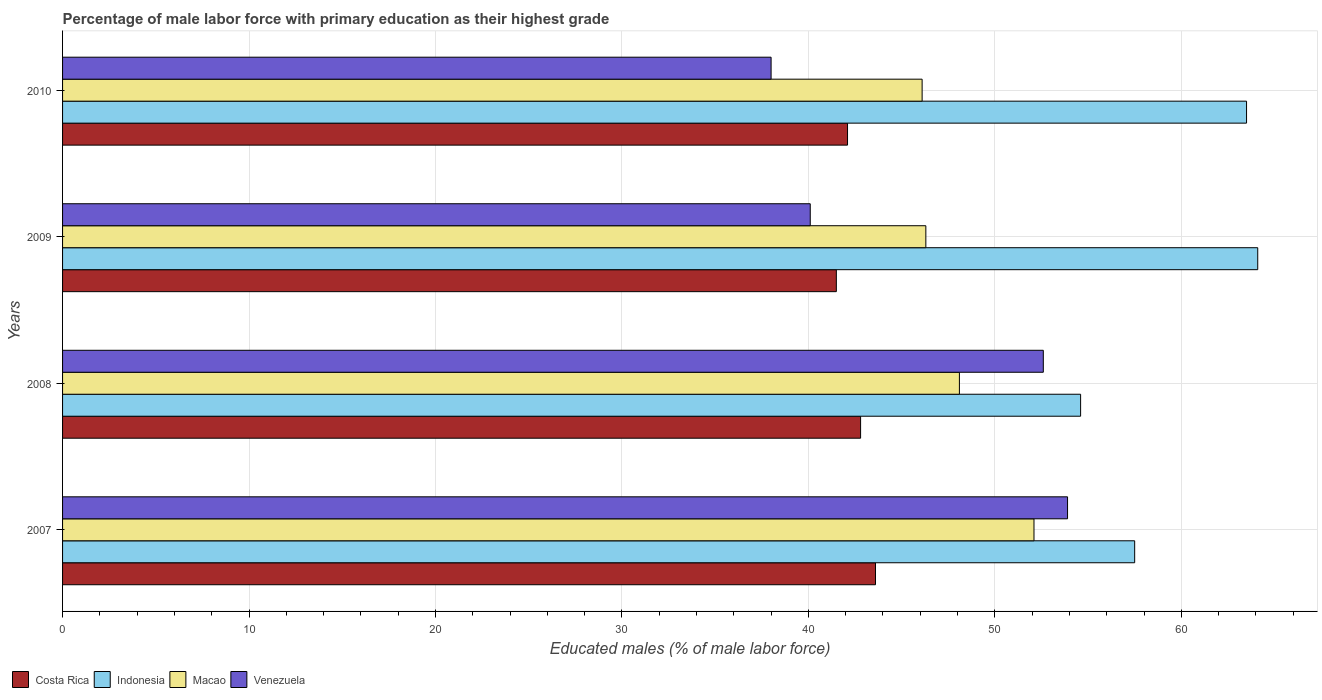How many different coloured bars are there?
Your response must be concise. 4. How many groups of bars are there?
Your answer should be compact. 4. Are the number of bars per tick equal to the number of legend labels?
Make the answer very short. Yes. How many bars are there on the 4th tick from the top?
Provide a short and direct response. 4. How many bars are there on the 1st tick from the bottom?
Provide a short and direct response. 4. What is the label of the 1st group of bars from the top?
Ensure brevity in your answer.  2010. In how many cases, is the number of bars for a given year not equal to the number of legend labels?
Provide a short and direct response. 0. What is the percentage of male labor force with primary education in Venezuela in 2007?
Offer a very short reply. 53.9. Across all years, what is the maximum percentage of male labor force with primary education in Venezuela?
Offer a very short reply. 53.9. Across all years, what is the minimum percentage of male labor force with primary education in Costa Rica?
Your answer should be very brief. 41.5. In which year was the percentage of male labor force with primary education in Macao maximum?
Your response must be concise. 2007. What is the total percentage of male labor force with primary education in Macao in the graph?
Offer a terse response. 192.6. What is the difference between the percentage of male labor force with primary education in Indonesia in 2007 and that in 2009?
Offer a very short reply. -6.6. What is the difference between the percentage of male labor force with primary education in Venezuela in 2009 and the percentage of male labor force with primary education in Indonesia in 2007?
Provide a succinct answer. -17.4. What is the average percentage of male labor force with primary education in Venezuela per year?
Provide a succinct answer. 46.15. In the year 2009, what is the difference between the percentage of male labor force with primary education in Venezuela and percentage of male labor force with primary education in Indonesia?
Offer a very short reply. -24. In how many years, is the percentage of male labor force with primary education in Costa Rica greater than 22 %?
Give a very brief answer. 4. What is the ratio of the percentage of male labor force with primary education in Indonesia in 2009 to that in 2010?
Your answer should be very brief. 1.01. In how many years, is the percentage of male labor force with primary education in Indonesia greater than the average percentage of male labor force with primary education in Indonesia taken over all years?
Give a very brief answer. 2. What does the 2nd bar from the top in 2007 represents?
Give a very brief answer. Macao. Is it the case that in every year, the sum of the percentage of male labor force with primary education in Venezuela and percentage of male labor force with primary education in Indonesia is greater than the percentage of male labor force with primary education in Macao?
Offer a very short reply. Yes. How many bars are there?
Give a very brief answer. 16. Are all the bars in the graph horizontal?
Keep it short and to the point. Yes. How many years are there in the graph?
Make the answer very short. 4. What is the difference between two consecutive major ticks on the X-axis?
Your answer should be compact. 10. Are the values on the major ticks of X-axis written in scientific E-notation?
Ensure brevity in your answer.  No. Does the graph contain grids?
Make the answer very short. Yes. What is the title of the graph?
Offer a terse response. Percentage of male labor force with primary education as their highest grade. Does "Cayman Islands" appear as one of the legend labels in the graph?
Keep it short and to the point. No. What is the label or title of the X-axis?
Provide a succinct answer. Educated males (% of male labor force). What is the Educated males (% of male labor force) in Costa Rica in 2007?
Offer a terse response. 43.6. What is the Educated males (% of male labor force) of Indonesia in 2007?
Provide a short and direct response. 57.5. What is the Educated males (% of male labor force) of Macao in 2007?
Keep it short and to the point. 52.1. What is the Educated males (% of male labor force) of Venezuela in 2007?
Give a very brief answer. 53.9. What is the Educated males (% of male labor force) in Costa Rica in 2008?
Offer a terse response. 42.8. What is the Educated males (% of male labor force) of Indonesia in 2008?
Provide a succinct answer. 54.6. What is the Educated males (% of male labor force) of Macao in 2008?
Give a very brief answer. 48.1. What is the Educated males (% of male labor force) of Venezuela in 2008?
Make the answer very short. 52.6. What is the Educated males (% of male labor force) in Costa Rica in 2009?
Offer a terse response. 41.5. What is the Educated males (% of male labor force) of Indonesia in 2009?
Make the answer very short. 64.1. What is the Educated males (% of male labor force) in Macao in 2009?
Keep it short and to the point. 46.3. What is the Educated males (% of male labor force) of Venezuela in 2009?
Provide a succinct answer. 40.1. What is the Educated males (% of male labor force) in Costa Rica in 2010?
Your answer should be very brief. 42.1. What is the Educated males (% of male labor force) in Indonesia in 2010?
Keep it short and to the point. 63.5. What is the Educated males (% of male labor force) in Macao in 2010?
Keep it short and to the point. 46.1. What is the Educated males (% of male labor force) of Venezuela in 2010?
Make the answer very short. 38. Across all years, what is the maximum Educated males (% of male labor force) in Costa Rica?
Your answer should be very brief. 43.6. Across all years, what is the maximum Educated males (% of male labor force) in Indonesia?
Offer a terse response. 64.1. Across all years, what is the maximum Educated males (% of male labor force) in Macao?
Offer a very short reply. 52.1. Across all years, what is the maximum Educated males (% of male labor force) of Venezuela?
Ensure brevity in your answer.  53.9. Across all years, what is the minimum Educated males (% of male labor force) in Costa Rica?
Offer a very short reply. 41.5. Across all years, what is the minimum Educated males (% of male labor force) of Indonesia?
Provide a succinct answer. 54.6. Across all years, what is the minimum Educated males (% of male labor force) in Macao?
Give a very brief answer. 46.1. What is the total Educated males (% of male labor force) of Costa Rica in the graph?
Make the answer very short. 170. What is the total Educated males (% of male labor force) in Indonesia in the graph?
Provide a short and direct response. 239.7. What is the total Educated males (% of male labor force) of Macao in the graph?
Offer a very short reply. 192.6. What is the total Educated males (% of male labor force) of Venezuela in the graph?
Keep it short and to the point. 184.6. What is the difference between the Educated males (% of male labor force) of Costa Rica in 2007 and that in 2008?
Provide a short and direct response. 0.8. What is the difference between the Educated males (% of male labor force) of Venezuela in 2007 and that in 2008?
Offer a terse response. 1.3. What is the difference between the Educated males (% of male labor force) in Indonesia in 2007 and that in 2009?
Offer a very short reply. -6.6. What is the difference between the Educated males (% of male labor force) of Indonesia in 2007 and that in 2010?
Make the answer very short. -6. What is the difference between the Educated males (% of male labor force) in Macao in 2007 and that in 2010?
Your answer should be compact. 6. What is the difference between the Educated males (% of male labor force) in Costa Rica in 2008 and that in 2009?
Your answer should be compact. 1.3. What is the difference between the Educated males (% of male labor force) in Macao in 2008 and that in 2009?
Keep it short and to the point. 1.8. What is the difference between the Educated males (% of male labor force) of Venezuela in 2008 and that in 2009?
Provide a succinct answer. 12.5. What is the difference between the Educated males (% of male labor force) in Indonesia in 2008 and that in 2010?
Offer a very short reply. -8.9. What is the difference between the Educated males (% of male labor force) in Macao in 2008 and that in 2010?
Ensure brevity in your answer.  2. What is the difference between the Educated males (% of male labor force) of Venezuela in 2008 and that in 2010?
Provide a short and direct response. 14.6. What is the difference between the Educated males (% of male labor force) in Macao in 2009 and that in 2010?
Provide a succinct answer. 0.2. What is the difference between the Educated males (% of male labor force) in Costa Rica in 2007 and the Educated males (% of male labor force) in Indonesia in 2008?
Give a very brief answer. -11. What is the difference between the Educated males (% of male labor force) of Costa Rica in 2007 and the Educated males (% of male labor force) of Venezuela in 2008?
Ensure brevity in your answer.  -9. What is the difference between the Educated males (% of male labor force) of Indonesia in 2007 and the Educated males (% of male labor force) of Macao in 2008?
Give a very brief answer. 9.4. What is the difference between the Educated males (% of male labor force) in Macao in 2007 and the Educated males (% of male labor force) in Venezuela in 2008?
Your answer should be very brief. -0.5. What is the difference between the Educated males (% of male labor force) of Costa Rica in 2007 and the Educated males (% of male labor force) of Indonesia in 2009?
Give a very brief answer. -20.5. What is the difference between the Educated males (% of male labor force) in Indonesia in 2007 and the Educated males (% of male labor force) in Macao in 2009?
Your response must be concise. 11.2. What is the difference between the Educated males (% of male labor force) in Costa Rica in 2007 and the Educated males (% of male labor force) in Indonesia in 2010?
Keep it short and to the point. -19.9. What is the difference between the Educated males (% of male labor force) of Costa Rica in 2007 and the Educated males (% of male labor force) of Macao in 2010?
Your answer should be compact. -2.5. What is the difference between the Educated males (% of male labor force) in Indonesia in 2007 and the Educated males (% of male labor force) in Macao in 2010?
Make the answer very short. 11.4. What is the difference between the Educated males (% of male labor force) in Indonesia in 2007 and the Educated males (% of male labor force) in Venezuela in 2010?
Your answer should be compact. 19.5. What is the difference between the Educated males (% of male labor force) in Macao in 2007 and the Educated males (% of male labor force) in Venezuela in 2010?
Make the answer very short. 14.1. What is the difference between the Educated males (% of male labor force) in Costa Rica in 2008 and the Educated males (% of male labor force) in Indonesia in 2009?
Keep it short and to the point. -21.3. What is the difference between the Educated males (% of male labor force) in Costa Rica in 2008 and the Educated males (% of male labor force) in Venezuela in 2009?
Provide a succinct answer. 2.7. What is the difference between the Educated males (% of male labor force) of Indonesia in 2008 and the Educated males (% of male labor force) of Macao in 2009?
Offer a very short reply. 8.3. What is the difference between the Educated males (% of male labor force) of Indonesia in 2008 and the Educated males (% of male labor force) of Venezuela in 2009?
Make the answer very short. 14.5. What is the difference between the Educated males (% of male labor force) of Macao in 2008 and the Educated males (% of male labor force) of Venezuela in 2009?
Your answer should be compact. 8. What is the difference between the Educated males (% of male labor force) of Costa Rica in 2008 and the Educated males (% of male labor force) of Indonesia in 2010?
Offer a very short reply. -20.7. What is the difference between the Educated males (% of male labor force) of Costa Rica in 2008 and the Educated males (% of male labor force) of Macao in 2010?
Make the answer very short. -3.3. What is the difference between the Educated males (% of male labor force) in Costa Rica in 2008 and the Educated males (% of male labor force) in Venezuela in 2010?
Give a very brief answer. 4.8. What is the difference between the Educated males (% of male labor force) in Indonesia in 2008 and the Educated males (% of male labor force) in Venezuela in 2010?
Your answer should be compact. 16.6. What is the difference between the Educated males (% of male labor force) of Costa Rica in 2009 and the Educated males (% of male labor force) of Indonesia in 2010?
Provide a short and direct response. -22. What is the difference between the Educated males (% of male labor force) of Indonesia in 2009 and the Educated males (% of male labor force) of Macao in 2010?
Give a very brief answer. 18. What is the difference between the Educated males (% of male labor force) of Indonesia in 2009 and the Educated males (% of male labor force) of Venezuela in 2010?
Your response must be concise. 26.1. What is the difference between the Educated males (% of male labor force) of Macao in 2009 and the Educated males (% of male labor force) of Venezuela in 2010?
Offer a terse response. 8.3. What is the average Educated males (% of male labor force) of Costa Rica per year?
Make the answer very short. 42.5. What is the average Educated males (% of male labor force) of Indonesia per year?
Make the answer very short. 59.92. What is the average Educated males (% of male labor force) in Macao per year?
Your answer should be very brief. 48.15. What is the average Educated males (% of male labor force) in Venezuela per year?
Make the answer very short. 46.15. In the year 2007, what is the difference between the Educated males (% of male labor force) in Costa Rica and Educated males (% of male labor force) in Macao?
Give a very brief answer. -8.5. In the year 2007, what is the difference between the Educated males (% of male labor force) of Indonesia and Educated males (% of male labor force) of Macao?
Your answer should be compact. 5.4. In the year 2008, what is the difference between the Educated males (% of male labor force) in Costa Rica and Educated males (% of male labor force) in Indonesia?
Offer a very short reply. -11.8. In the year 2008, what is the difference between the Educated males (% of male labor force) of Costa Rica and Educated males (% of male labor force) of Macao?
Keep it short and to the point. -5.3. In the year 2008, what is the difference between the Educated males (% of male labor force) of Indonesia and Educated males (% of male labor force) of Macao?
Keep it short and to the point. 6.5. In the year 2008, what is the difference between the Educated males (% of male labor force) in Indonesia and Educated males (% of male labor force) in Venezuela?
Your answer should be very brief. 2. In the year 2009, what is the difference between the Educated males (% of male labor force) in Costa Rica and Educated males (% of male labor force) in Indonesia?
Your answer should be compact. -22.6. In the year 2009, what is the difference between the Educated males (% of male labor force) in Indonesia and Educated males (% of male labor force) in Venezuela?
Your response must be concise. 24. In the year 2009, what is the difference between the Educated males (% of male labor force) in Macao and Educated males (% of male labor force) in Venezuela?
Keep it short and to the point. 6.2. In the year 2010, what is the difference between the Educated males (% of male labor force) of Costa Rica and Educated males (% of male labor force) of Indonesia?
Ensure brevity in your answer.  -21.4. In the year 2010, what is the difference between the Educated males (% of male labor force) in Costa Rica and Educated males (% of male labor force) in Macao?
Make the answer very short. -4. In the year 2010, what is the difference between the Educated males (% of male labor force) of Costa Rica and Educated males (% of male labor force) of Venezuela?
Offer a terse response. 4.1. What is the ratio of the Educated males (% of male labor force) in Costa Rica in 2007 to that in 2008?
Ensure brevity in your answer.  1.02. What is the ratio of the Educated males (% of male labor force) in Indonesia in 2007 to that in 2008?
Provide a short and direct response. 1.05. What is the ratio of the Educated males (% of male labor force) in Macao in 2007 to that in 2008?
Provide a succinct answer. 1.08. What is the ratio of the Educated males (% of male labor force) in Venezuela in 2007 to that in 2008?
Your answer should be very brief. 1.02. What is the ratio of the Educated males (% of male labor force) in Costa Rica in 2007 to that in 2009?
Keep it short and to the point. 1.05. What is the ratio of the Educated males (% of male labor force) of Indonesia in 2007 to that in 2009?
Give a very brief answer. 0.9. What is the ratio of the Educated males (% of male labor force) in Macao in 2007 to that in 2009?
Offer a terse response. 1.13. What is the ratio of the Educated males (% of male labor force) in Venezuela in 2007 to that in 2009?
Give a very brief answer. 1.34. What is the ratio of the Educated males (% of male labor force) in Costa Rica in 2007 to that in 2010?
Offer a terse response. 1.04. What is the ratio of the Educated males (% of male labor force) in Indonesia in 2007 to that in 2010?
Your response must be concise. 0.91. What is the ratio of the Educated males (% of male labor force) in Macao in 2007 to that in 2010?
Ensure brevity in your answer.  1.13. What is the ratio of the Educated males (% of male labor force) in Venezuela in 2007 to that in 2010?
Your response must be concise. 1.42. What is the ratio of the Educated males (% of male labor force) of Costa Rica in 2008 to that in 2009?
Offer a terse response. 1.03. What is the ratio of the Educated males (% of male labor force) of Indonesia in 2008 to that in 2009?
Keep it short and to the point. 0.85. What is the ratio of the Educated males (% of male labor force) of Macao in 2008 to that in 2009?
Make the answer very short. 1.04. What is the ratio of the Educated males (% of male labor force) in Venezuela in 2008 to that in 2009?
Your response must be concise. 1.31. What is the ratio of the Educated males (% of male labor force) of Costa Rica in 2008 to that in 2010?
Provide a succinct answer. 1.02. What is the ratio of the Educated males (% of male labor force) in Indonesia in 2008 to that in 2010?
Ensure brevity in your answer.  0.86. What is the ratio of the Educated males (% of male labor force) in Macao in 2008 to that in 2010?
Your answer should be compact. 1.04. What is the ratio of the Educated males (% of male labor force) of Venezuela in 2008 to that in 2010?
Your answer should be very brief. 1.38. What is the ratio of the Educated males (% of male labor force) in Costa Rica in 2009 to that in 2010?
Provide a short and direct response. 0.99. What is the ratio of the Educated males (% of male labor force) in Indonesia in 2009 to that in 2010?
Provide a short and direct response. 1.01. What is the ratio of the Educated males (% of male labor force) of Venezuela in 2009 to that in 2010?
Your answer should be compact. 1.06. What is the difference between the highest and the second highest Educated males (% of male labor force) in Costa Rica?
Provide a short and direct response. 0.8. What is the difference between the highest and the second highest Educated males (% of male labor force) of Macao?
Your answer should be compact. 4. What is the difference between the highest and the lowest Educated males (% of male labor force) of Macao?
Your response must be concise. 6. 